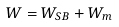Convert formula to latex. <formula><loc_0><loc_0><loc_500><loc_500>W = W _ { S B } + W _ { m }</formula> 